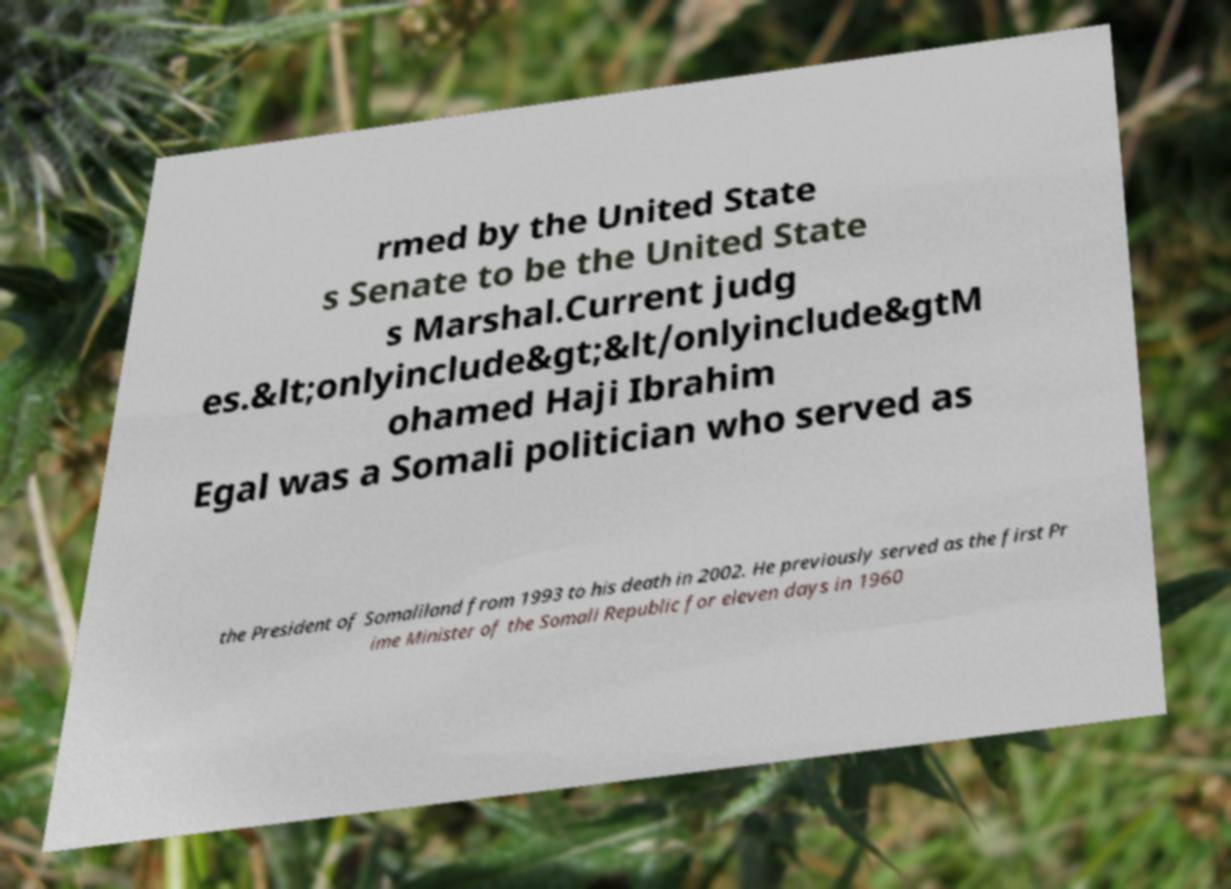For documentation purposes, I need the text within this image transcribed. Could you provide that? rmed by the United State s Senate to be the United State s Marshal.Current judg es.&lt;onlyinclude&gt;&lt/onlyinclude&gtM ohamed Haji Ibrahim Egal was a Somali politician who served as the President of Somaliland from 1993 to his death in 2002. He previously served as the first Pr ime Minister of the Somali Republic for eleven days in 1960 